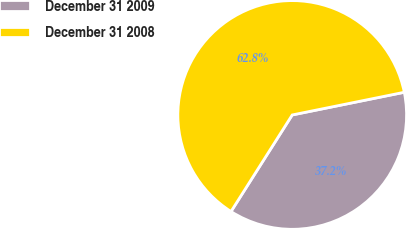Convert chart. <chart><loc_0><loc_0><loc_500><loc_500><pie_chart><fcel>December 31 2009<fcel>December 31 2008<nl><fcel>37.17%<fcel>62.83%<nl></chart> 